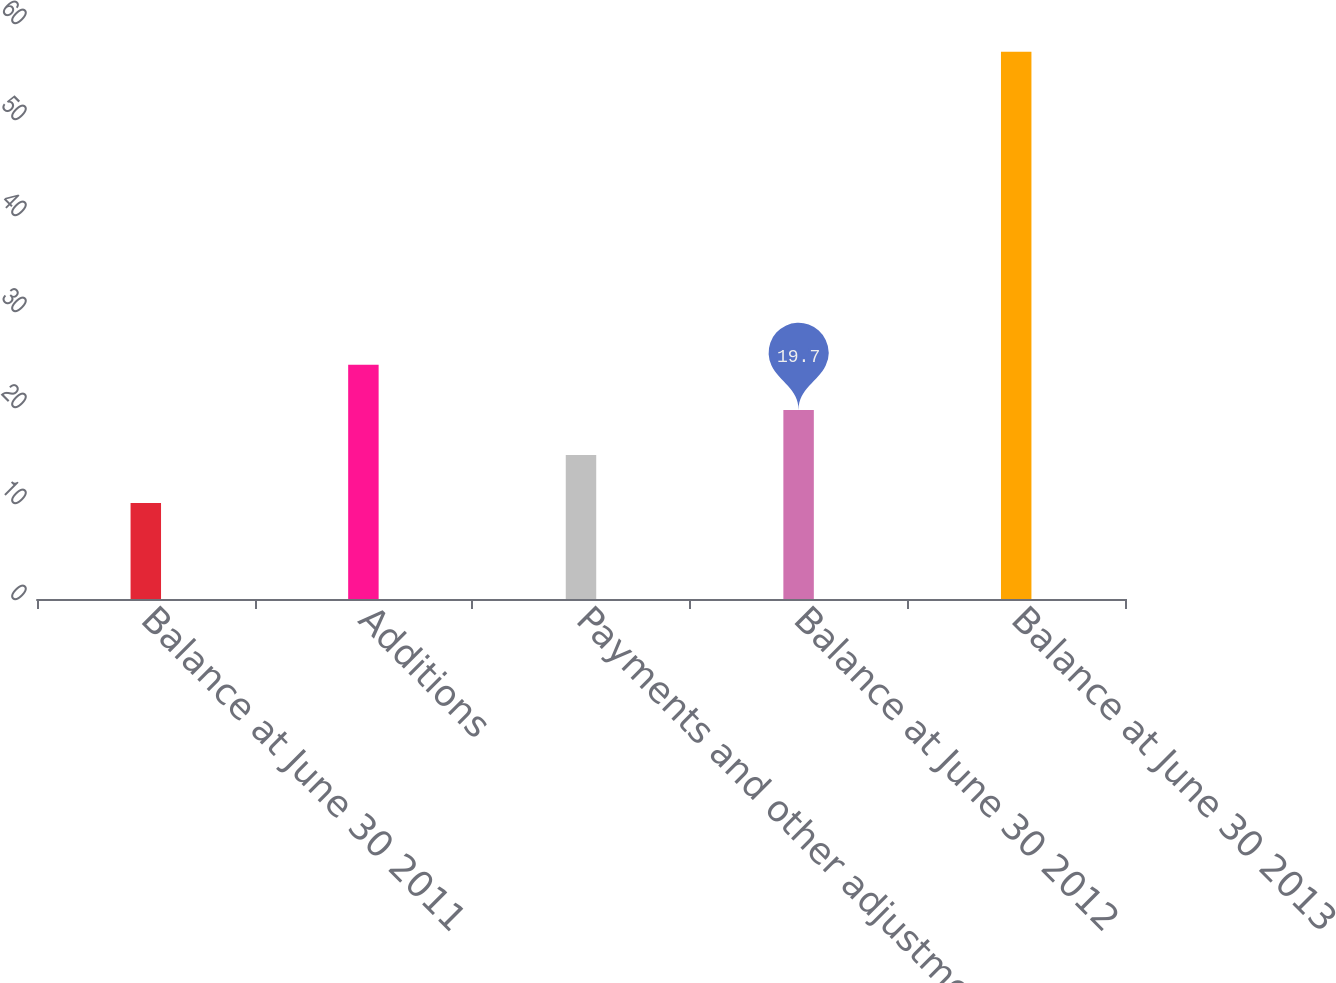Convert chart to OTSL. <chart><loc_0><loc_0><loc_500><loc_500><bar_chart><fcel>Balance at June 30 2011<fcel>Additions<fcel>Payments and other adjustments<fcel>Balance at June 30 2012<fcel>Balance at June 30 2013<nl><fcel>10<fcel>24.4<fcel>15<fcel>19.7<fcel>57<nl></chart> 